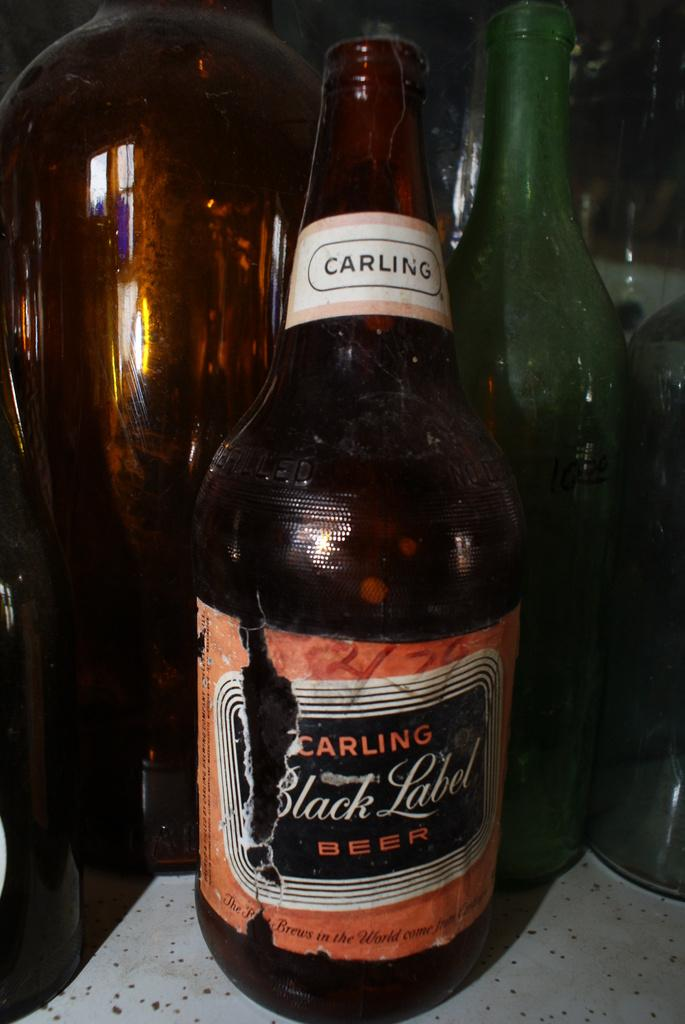Provide a one-sentence caption for the provided image. Several bottles are on the table one of the bottles is a Carling Black Label Beer bottle. 